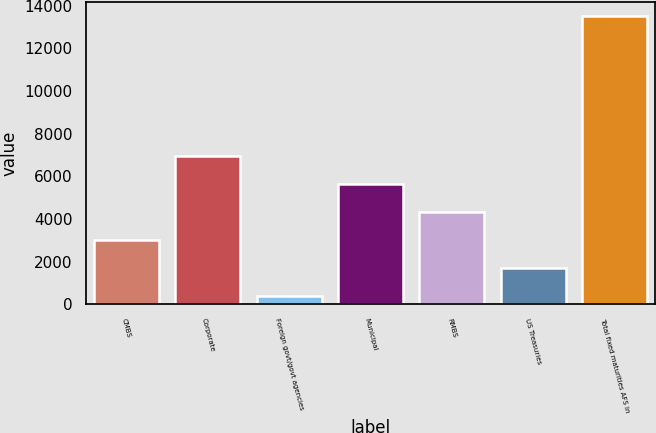Convert chart. <chart><loc_0><loc_0><loc_500><loc_500><bar_chart><fcel>CMBS<fcel>Corporate<fcel>Foreign govt/govt agencies<fcel>Municipal<fcel>RMBS<fcel>US Treasuries<fcel>Total fixed maturities AFS in<nl><fcel>3015.6<fcel>6952.5<fcel>391<fcel>5640.2<fcel>4327.9<fcel>1703.3<fcel>13514<nl></chart> 